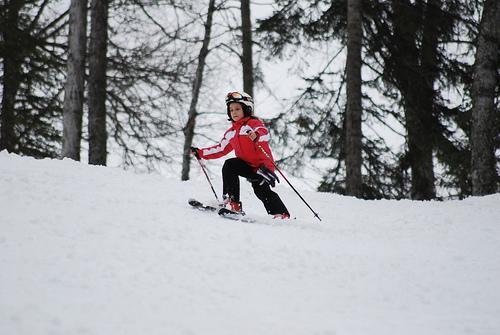How many orange pieces can you see?
Give a very brief answer. 0. 